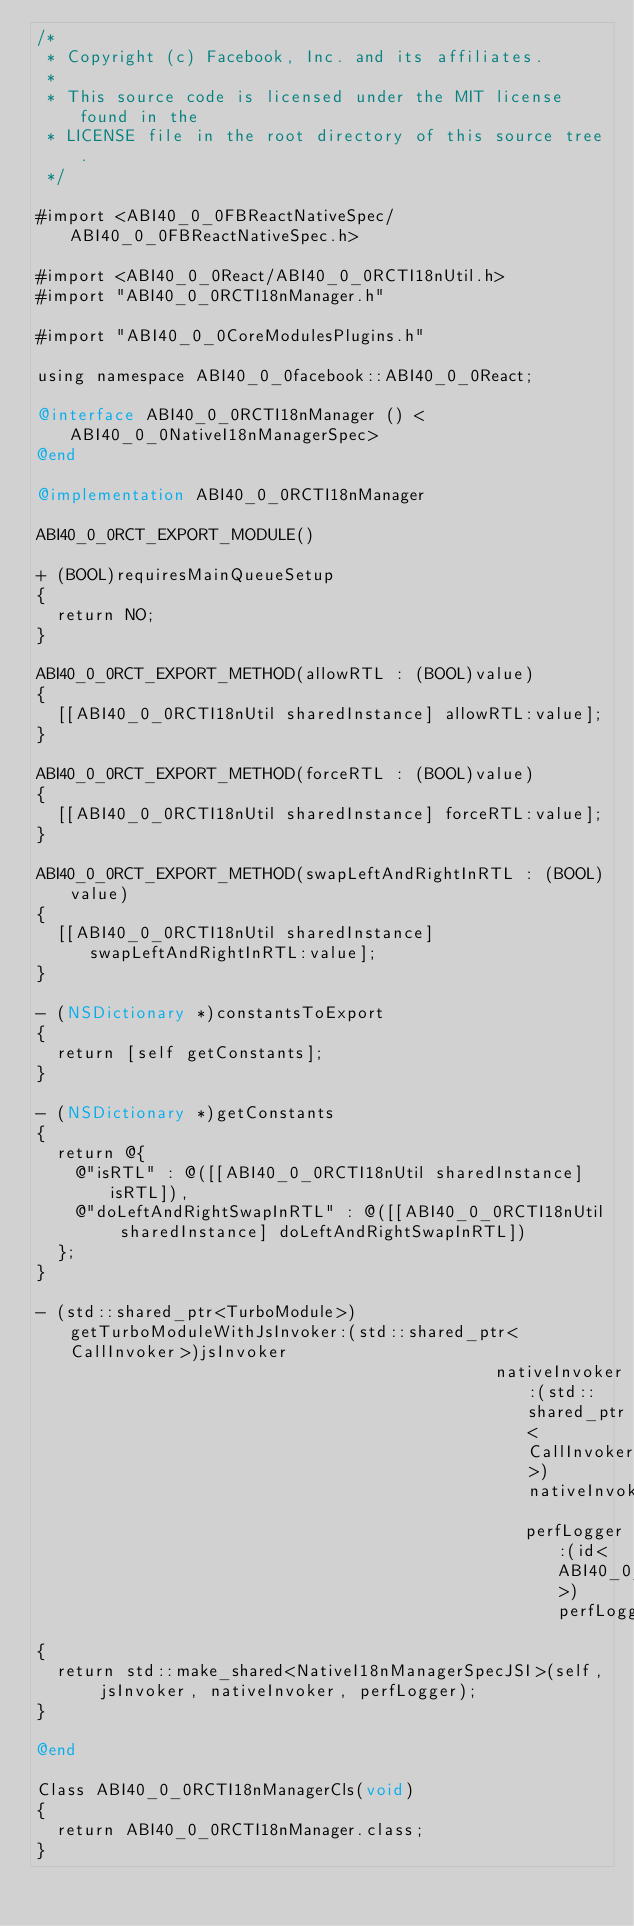Convert code to text. <code><loc_0><loc_0><loc_500><loc_500><_ObjectiveC_>/*
 * Copyright (c) Facebook, Inc. and its affiliates.
 *
 * This source code is licensed under the MIT license found in the
 * LICENSE file in the root directory of this source tree.
 */

#import <ABI40_0_0FBReactNativeSpec/ABI40_0_0FBReactNativeSpec.h>

#import <ABI40_0_0React/ABI40_0_0RCTI18nUtil.h>
#import "ABI40_0_0RCTI18nManager.h"

#import "ABI40_0_0CoreModulesPlugins.h"

using namespace ABI40_0_0facebook::ABI40_0_0React;

@interface ABI40_0_0RCTI18nManager () <ABI40_0_0NativeI18nManagerSpec>
@end

@implementation ABI40_0_0RCTI18nManager

ABI40_0_0RCT_EXPORT_MODULE()

+ (BOOL)requiresMainQueueSetup
{
  return NO;
}

ABI40_0_0RCT_EXPORT_METHOD(allowRTL : (BOOL)value)
{
  [[ABI40_0_0RCTI18nUtil sharedInstance] allowRTL:value];
}

ABI40_0_0RCT_EXPORT_METHOD(forceRTL : (BOOL)value)
{
  [[ABI40_0_0RCTI18nUtil sharedInstance] forceRTL:value];
}

ABI40_0_0RCT_EXPORT_METHOD(swapLeftAndRightInRTL : (BOOL)value)
{
  [[ABI40_0_0RCTI18nUtil sharedInstance] swapLeftAndRightInRTL:value];
}

- (NSDictionary *)constantsToExport
{
  return [self getConstants];
}

- (NSDictionary *)getConstants
{
  return @{
    @"isRTL" : @([[ABI40_0_0RCTI18nUtil sharedInstance] isRTL]),
    @"doLeftAndRightSwapInRTL" : @([[ABI40_0_0RCTI18nUtil sharedInstance] doLeftAndRightSwapInRTL])
  };
}

- (std::shared_ptr<TurboModule>)getTurboModuleWithJsInvoker:(std::shared_ptr<CallInvoker>)jsInvoker
                                              nativeInvoker:(std::shared_ptr<CallInvoker>)nativeInvoker
                                                 perfLogger:(id<ABI40_0_0RCTTurboModulePerformanceLogger>)perfLogger
{
  return std::make_shared<NativeI18nManagerSpecJSI>(self, jsInvoker, nativeInvoker, perfLogger);
}

@end

Class ABI40_0_0RCTI18nManagerCls(void)
{
  return ABI40_0_0RCTI18nManager.class;
}
</code> 